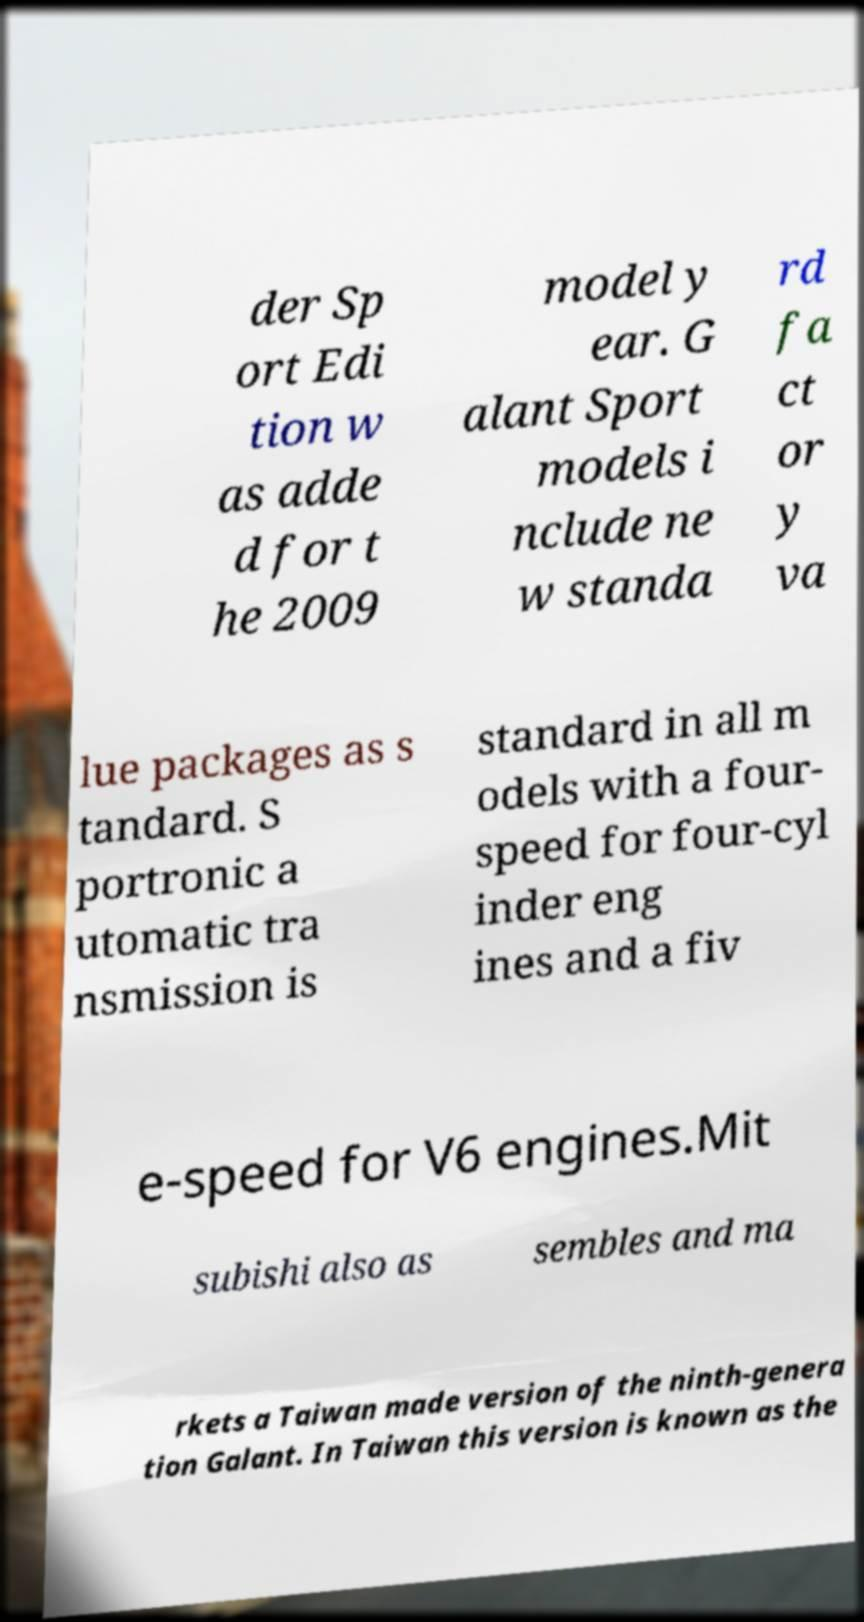What messages or text are displayed in this image? I need them in a readable, typed format. der Sp ort Edi tion w as adde d for t he 2009 model y ear. G alant Sport models i nclude ne w standa rd fa ct or y va lue packages as s tandard. S portronic a utomatic tra nsmission is standard in all m odels with a four- speed for four-cyl inder eng ines and a fiv e-speed for V6 engines.Mit subishi also as sembles and ma rkets a Taiwan made version of the ninth-genera tion Galant. In Taiwan this version is known as the 